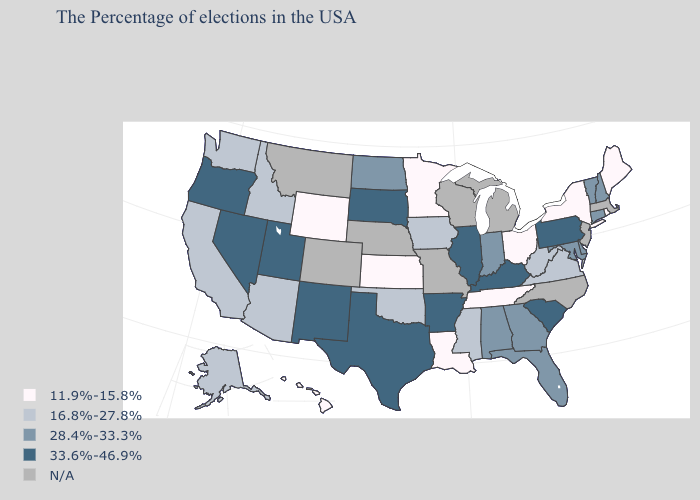What is the lowest value in the South?
Short answer required. 11.9%-15.8%. What is the lowest value in the West?
Short answer required. 11.9%-15.8%. What is the value of Minnesota?
Give a very brief answer. 11.9%-15.8%. Does the first symbol in the legend represent the smallest category?
Keep it brief. Yes. What is the value of Iowa?
Be succinct. 16.8%-27.8%. Name the states that have a value in the range 11.9%-15.8%?
Concise answer only. Maine, Rhode Island, New York, Ohio, Tennessee, Louisiana, Minnesota, Kansas, Wyoming, Hawaii. Is the legend a continuous bar?
Keep it brief. No. Among the states that border Texas , which have the lowest value?
Quick response, please. Louisiana. Name the states that have a value in the range 11.9%-15.8%?
Quick response, please. Maine, Rhode Island, New York, Ohio, Tennessee, Louisiana, Minnesota, Kansas, Wyoming, Hawaii. Name the states that have a value in the range N/A?
Be succinct. Massachusetts, New Jersey, North Carolina, Michigan, Wisconsin, Missouri, Nebraska, Colorado, Montana. What is the value of New Jersey?
Concise answer only. N/A. Name the states that have a value in the range N/A?
Give a very brief answer. Massachusetts, New Jersey, North Carolina, Michigan, Wisconsin, Missouri, Nebraska, Colorado, Montana. What is the value of Arkansas?
Short answer required. 33.6%-46.9%. Does Alaska have the highest value in the USA?
Be succinct. No. 